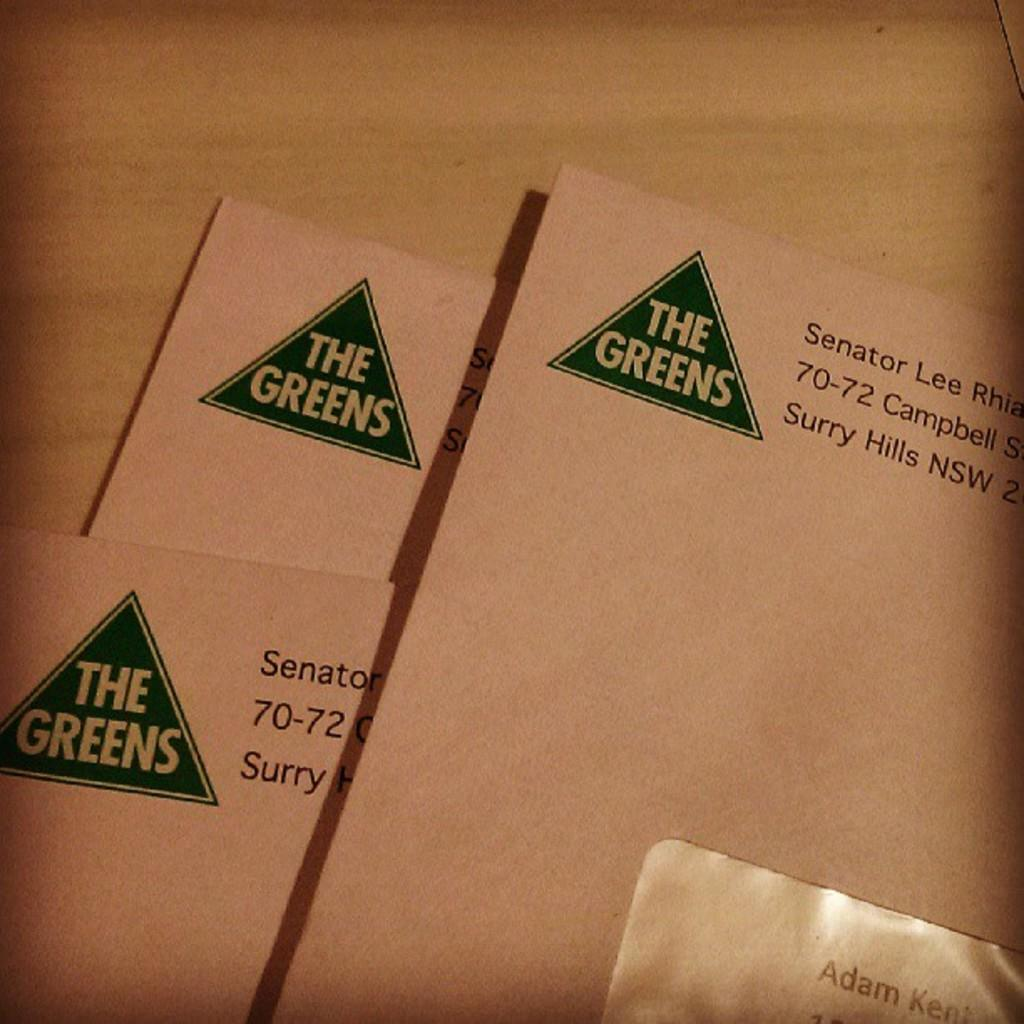<image>
Create a compact narrative representing the image presented. White envelopes with a green triangle in the left corner with The Greens printed inside the triangle. 